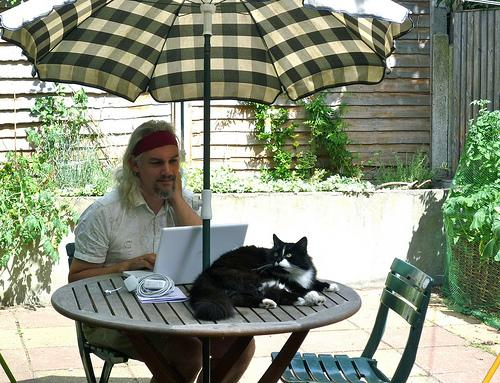Mention the key elements in the picture along with the primary action taking place. A man wearing a red headband is using a laptop at a patio table with a cat lying on it, and a vacant green chair nearby. Explain the relationship between the man and the cat in the image. The man and the cat are sharing an outdoor table, with the man working on his laptop and the cat laying down beside him. Describe the main human subject in the image and their attire. The man in the image is wearing a white buttondown shirt and a red headband, and is sitting at a patio table using a laptop. Provide a brief overall description of the scene in the image. A man and a cat are sharing an outdoor table under a green and white plaid umbrella, with the man using a laptop and the cat lying on the table. In one sentence, describe the primary actions taking place in the image. A man is working on his laptop at an outdoor table, with a cat lying down nearby and a vacant green chair sitting empty. Identify two subjects in the image and describe what they are doing. A man is sitting outdoors using a laptop, and a furry cat is laying on the table beside him. Enumerate three distinct elements present within the setting of the image. A green and white plaid umbrella, a vacant green patio chair, and ivy on a wooden wall. Describe the appearance of the cat in the image. The cat is black and white, long-haired, and has green eyes. It is laying down and appears to be alert. Describe the setting of the image, along with the main objects present. An outdoor patio area with a man sitting at a table using a laptop, a cat laying on the table, a green patio chair, and a green and white umbrella. Describe the main animal subject in the image and their position. A black and white, long-haired cat with green eyes is laying down on the patio table next to a laptop. 